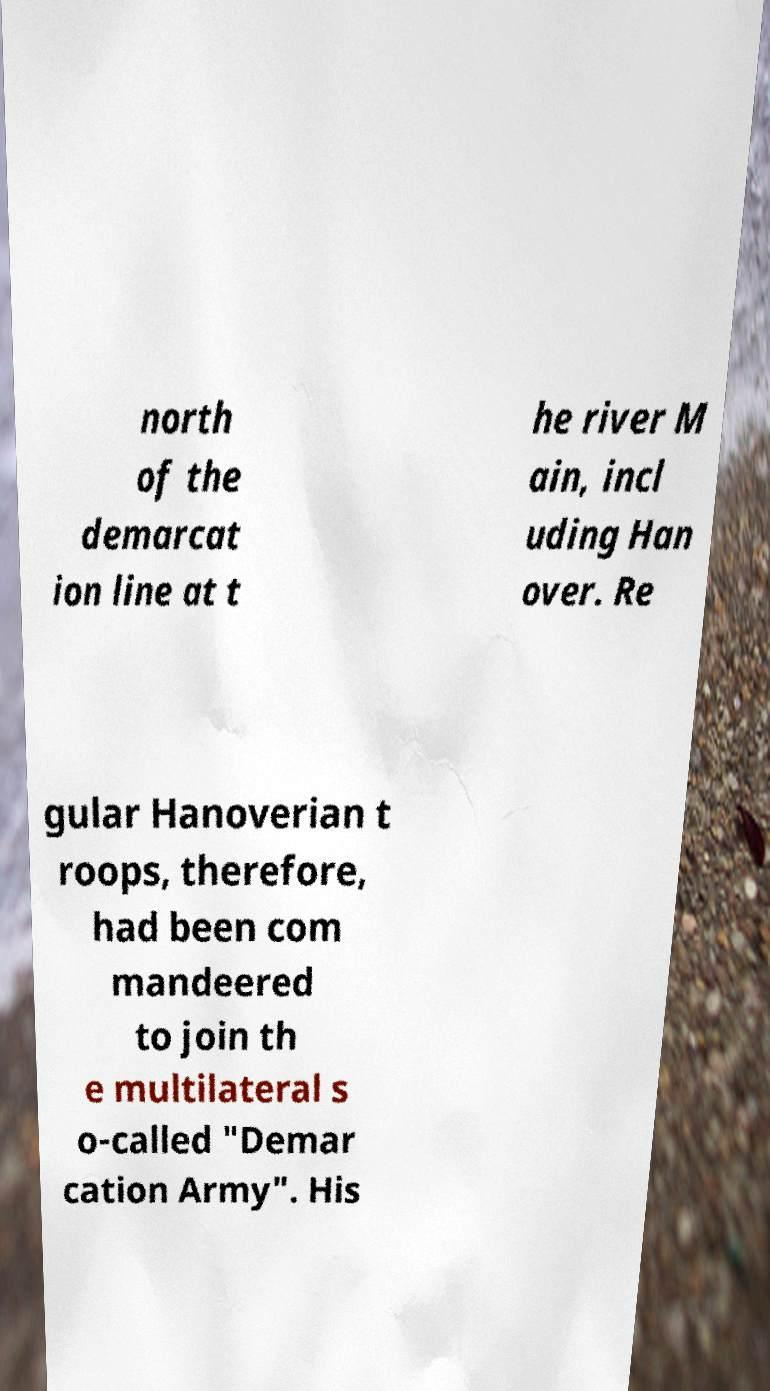What messages or text are displayed in this image? I need them in a readable, typed format. north of the demarcat ion line at t he river M ain, incl uding Han over. Re gular Hanoverian t roops, therefore, had been com mandeered to join th e multilateral s o-called "Demar cation Army". His 